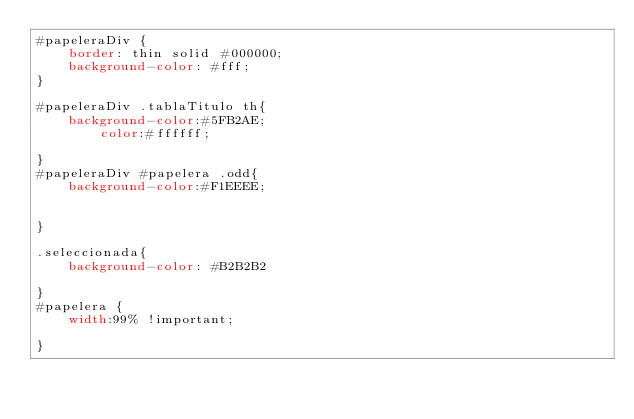<code> <loc_0><loc_0><loc_500><loc_500><_CSS_>#papeleraDiv {
	border: thin solid #000000;
	background-color: #fff;
}

#papeleraDiv .tablaTitulo th{
	background-color:#5FB2AE;
        color:#ffffff;
   
}
#papeleraDiv #papelera .odd{
	background-color:#F1EEEE;
     
  
}

.seleccionada{
	background-color: #B2B2B2 

}
#papelera {
	width:99% !important;
	
}</code> 